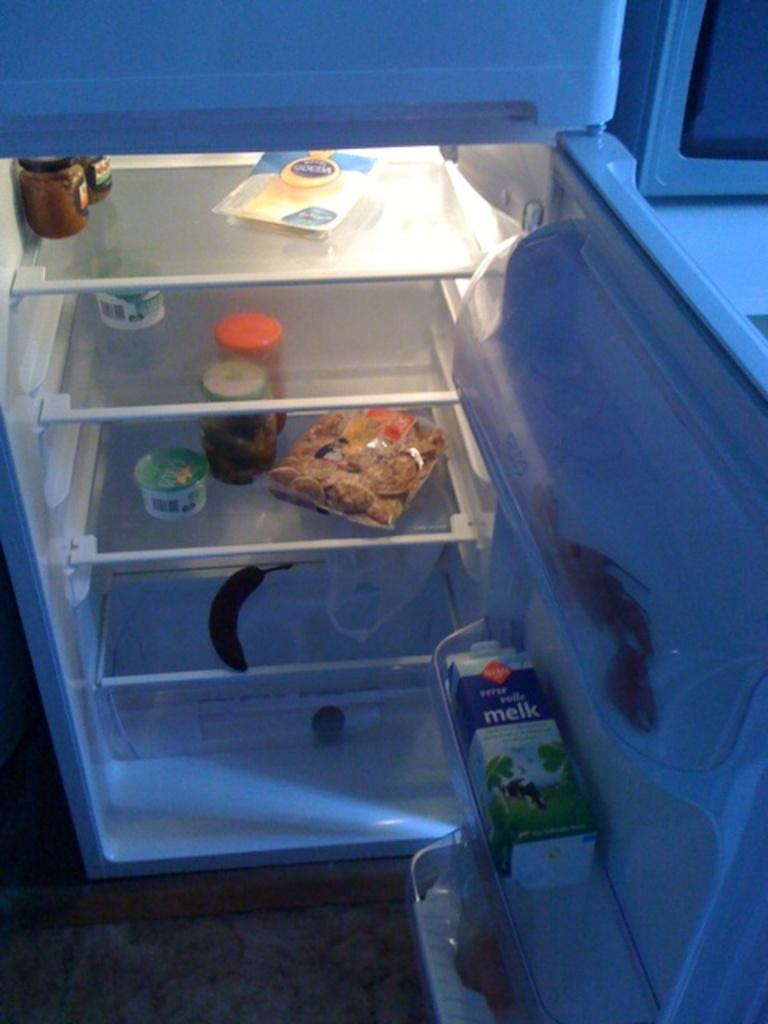<image>
Summarize the visual content of the image. A refrigerator with a brown banana and a carton the door labeled Melk. 